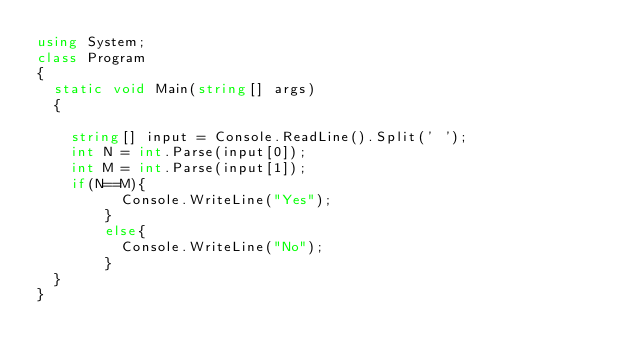Convert code to text. <code><loc_0><loc_0><loc_500><loc_500><_C#_>using System;
class Program
{
	static void Main(string[] args)
	{
		
		string[] input = Console.ReadLine().Split(' ');
		int N = int.Parse(input[0]);
		int M = int.Parse(input[1]);
		if(N==M){
          Console.WriteLine("Yes");
        }
        else{
          Console.WriteLine("No");
        }
	}
}</code> 